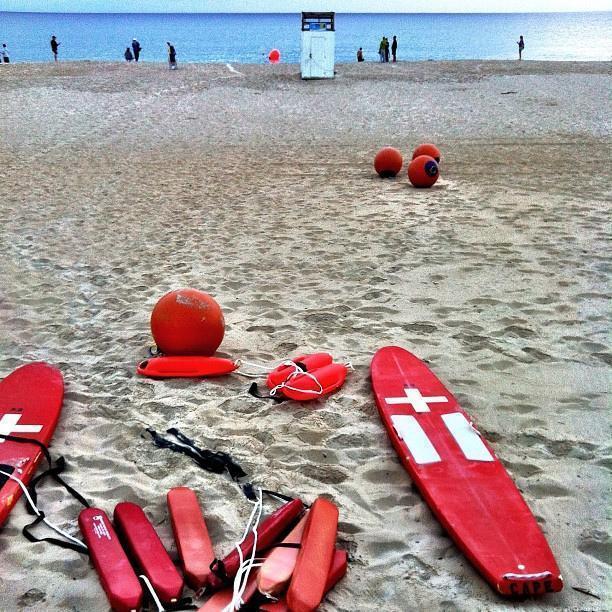Who does this gear on the beach belong to?
Choose the right answer from the provided options to respond to the question.
Options: Shore waste, school kids, bikini models, lifeguard. Lifeguard. 